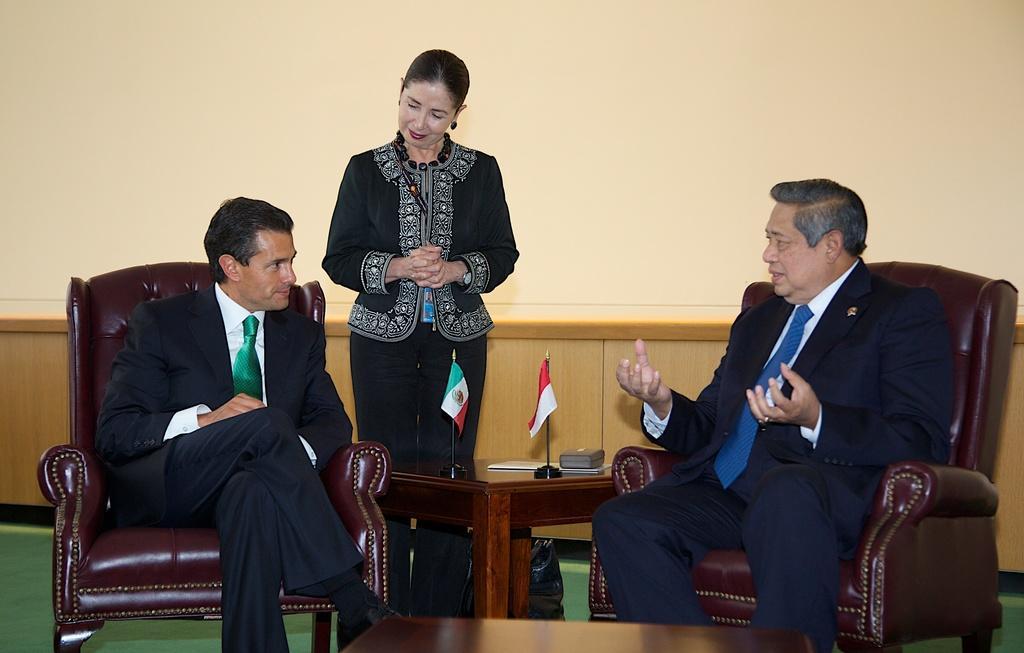Could you give a brief overview of what you see in this image? These two persons are sitting on a chair and wore suit and tie. This man is speaking with the other person, as there is a movement in his hands. In-between of this person's a woman is standing and wore black jacket. On this table there are flags, box and book. 